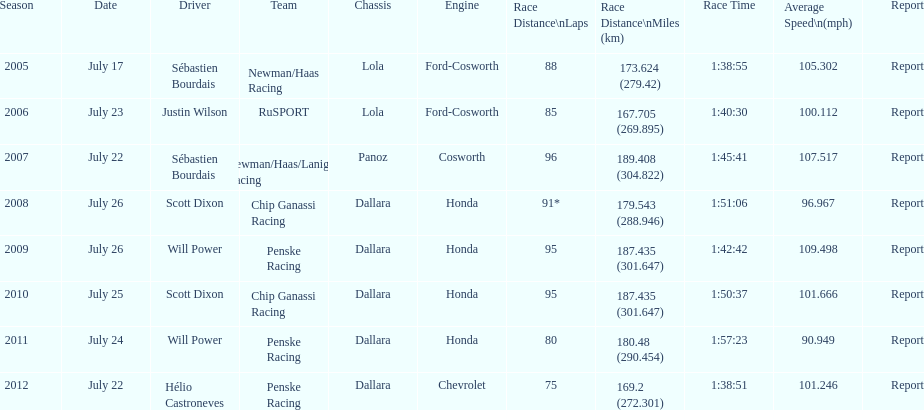How many total honda engines were there? 4. 